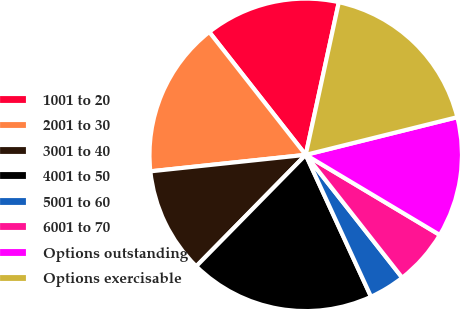Convert chart. <chart><loc_0><loc_0><loc_500><loc_500><pie_chart><fcel>1001 to 20<fcel>2001 to 30<fcel>3001 to 40<fcel>4001 to 50<fcel>5001 to 60<fcel>6001 to 70<fcel>Options outstanding<fcel>Options exercisable<nl><fcel>13.99%<fcel>16.09%<fcel>10.96%<fcel>19.22%<fcel>3.73%<fcel>5.83%<fcel>12.45%<fcel>17.72%<nl></chart> 